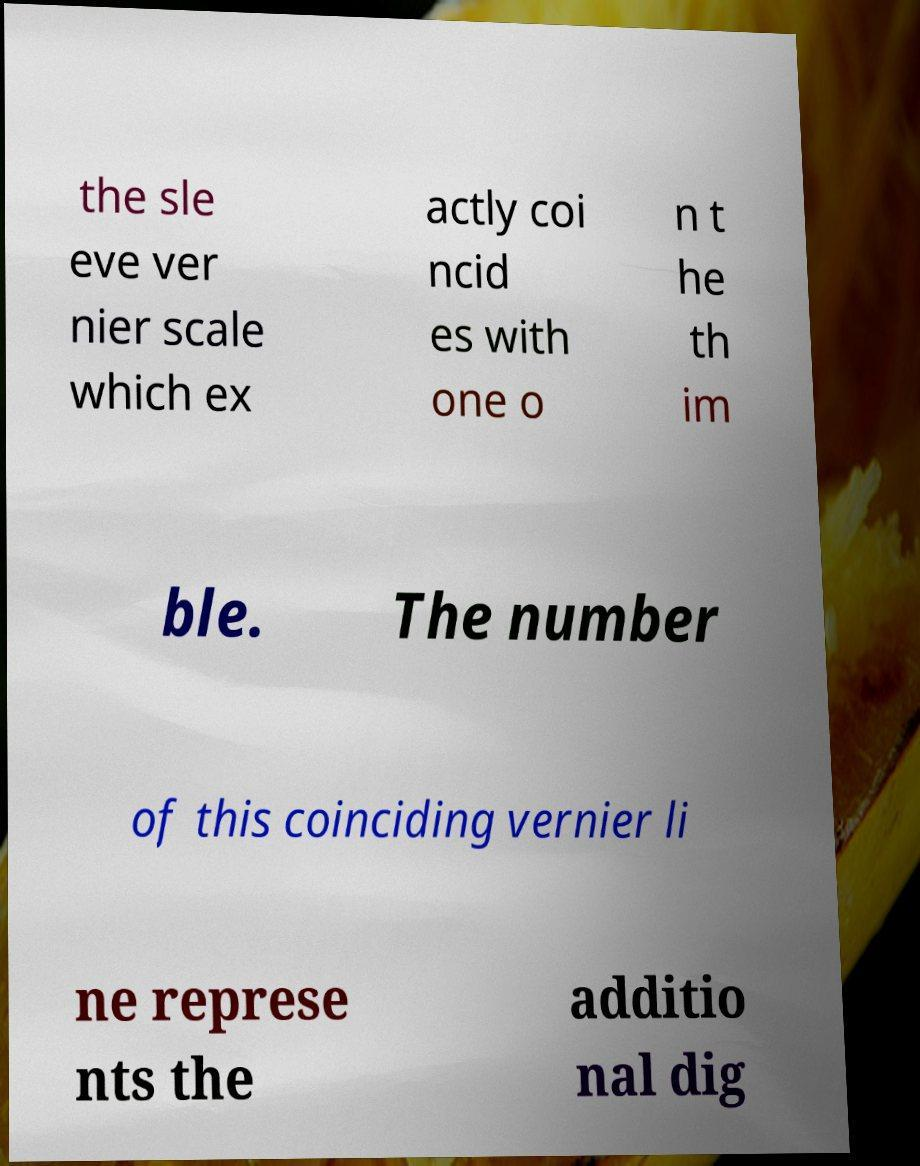Please read and relay the text visible in this image. What does it say? the sle eve ver nier scale which ex actly coi ncid es with one o n t he th im ble. The number of this coinciding vernier li ne represe nts the additio nal dig 